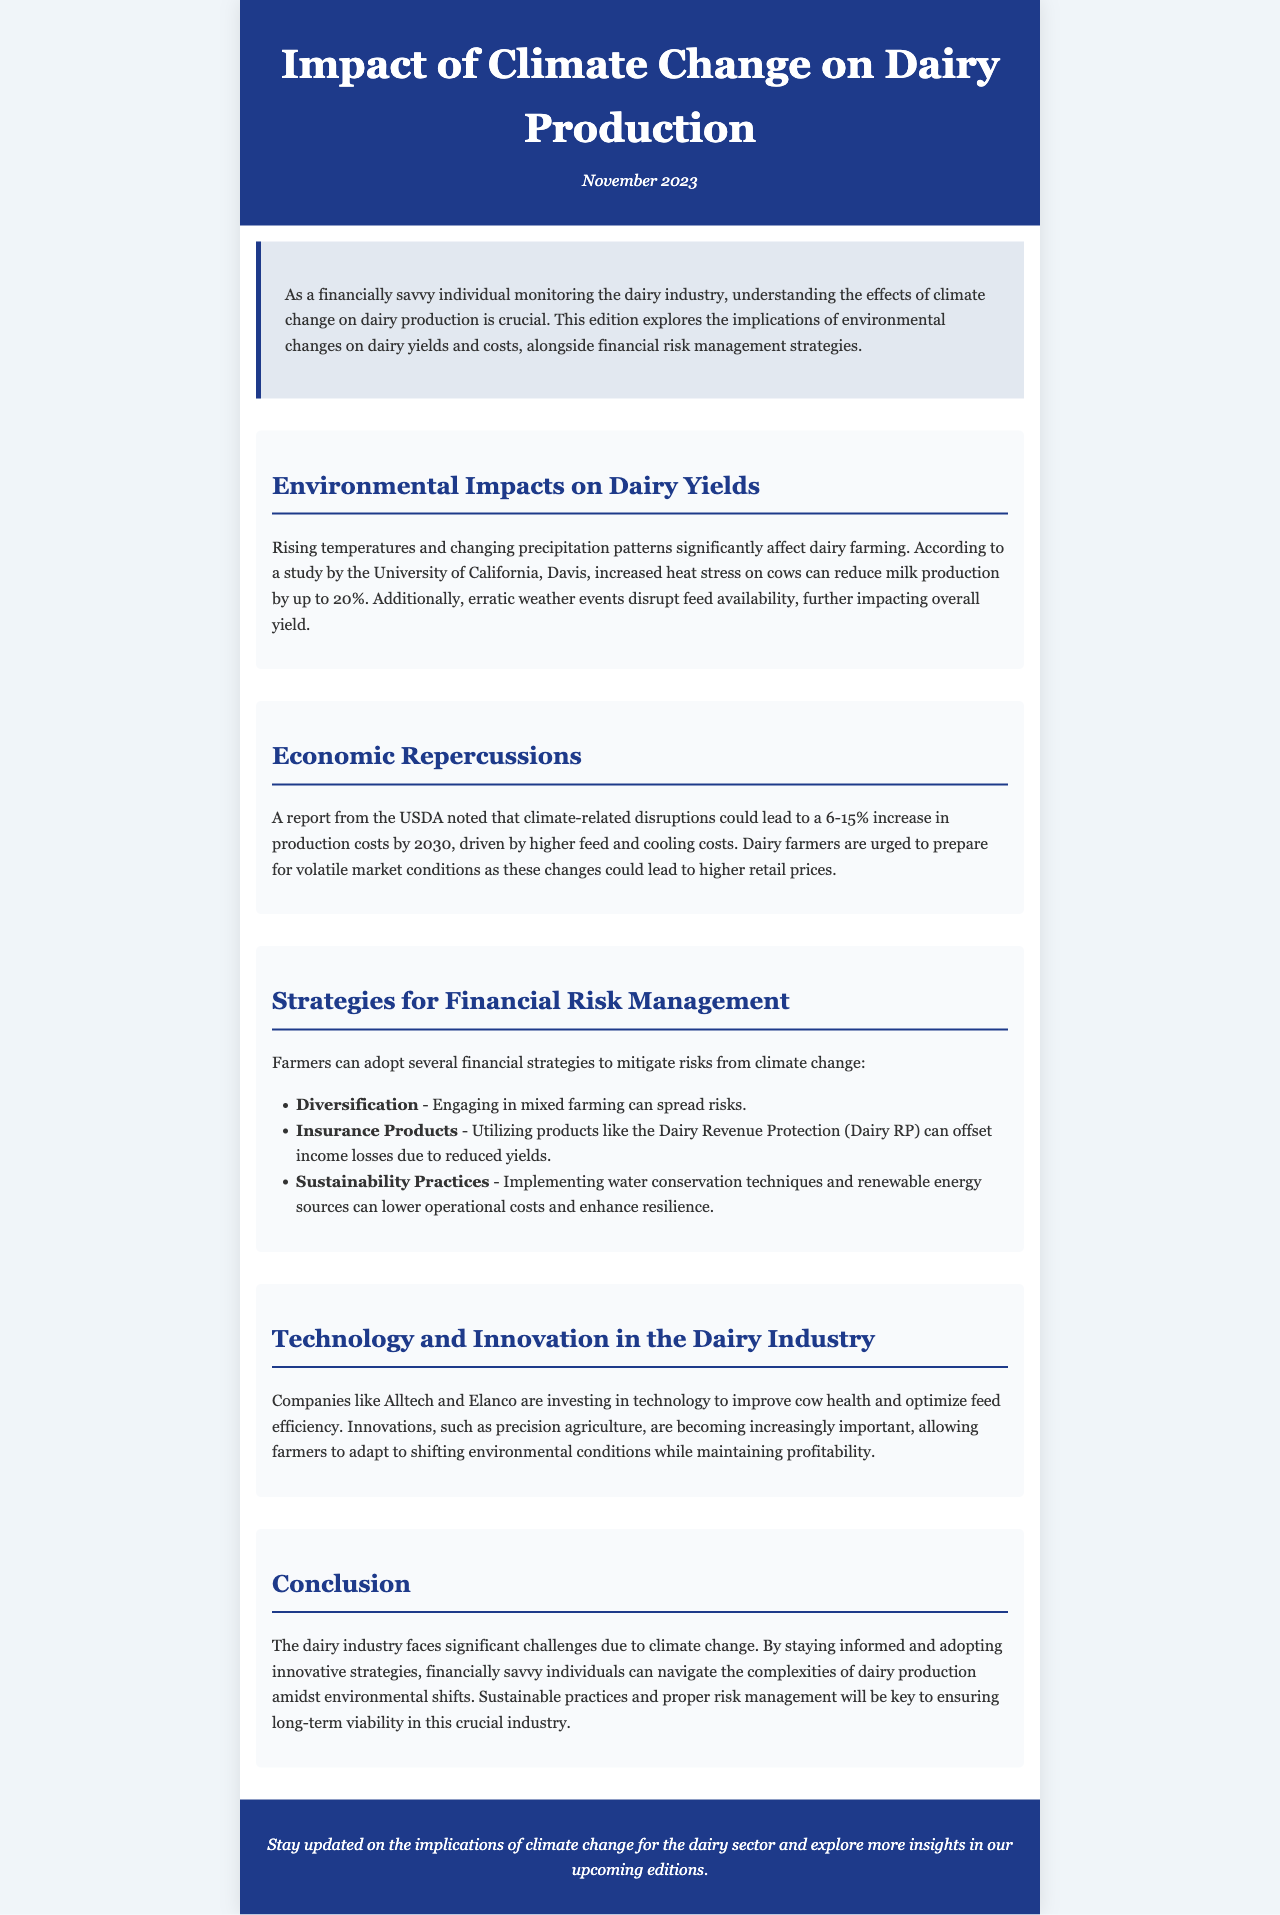What is the title of the newsletter? The title of the newsletter is presented in the header section.
Answer: Impact of Climate Change on Dairy Production What date is the newsletter published? The publication date is mentioned in the header section after the title.
Answer: November 2023 What can increased heat stress on cows reduce milk production by? This information is provided in the section discussing environmental impacts on dairy yields.
Answer: up to 20% By how much could climate-related disruptions increase production costs by 2030? This figure is mentioned in the economic repercussions section.
Answer: 6-15% What strategy can farmers use to spread risks? This strategy is outlined in the financial risk management strategies section.
Answer: Diversification Which companies are investing in technology to improve cow health? This information can be found in the section focused on technology and innovation.
Answer: Alltech and Elanco What is a product that can offset income losses due to reduced yields? This is mentioned in the financial risk management strategies section.
Answer: Dairy Revenue Protection What practices can lower operational costs and enhance resilience? This is discussed in the financial risk management section.
Answer: Sustainability Practices What is crucial for ensuring long-term viability in the dairy industry? This point is made in the conclusion of the newsletter.
Answer: Sustainable practices and proper risk management 